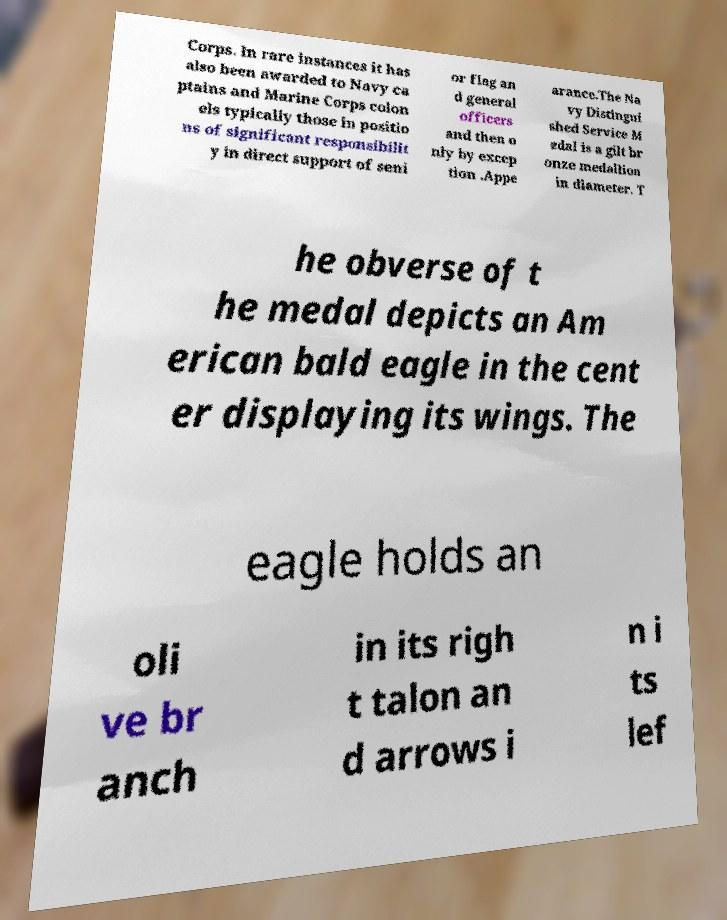There's text embedded in this image that I need extracted. Can you transcribe it verbatim? Corps. In rare instances it has also been awarded to Navy ca ptains and Marine Corps colon els typically those in positio ns of significant responsibilit y in direct support of seni or flag an d general officers and then o nly by excep tion .Appe arance.The Na vy Distingui shed Service M edal is a gilt br onze medallion in diameter. T he obverse of t he medal depicts an Am erican bald eagle in the cent er displaying its wings. The eagle holds an oli ve br anch in its righ t talon an d arrows i n i ts lef 